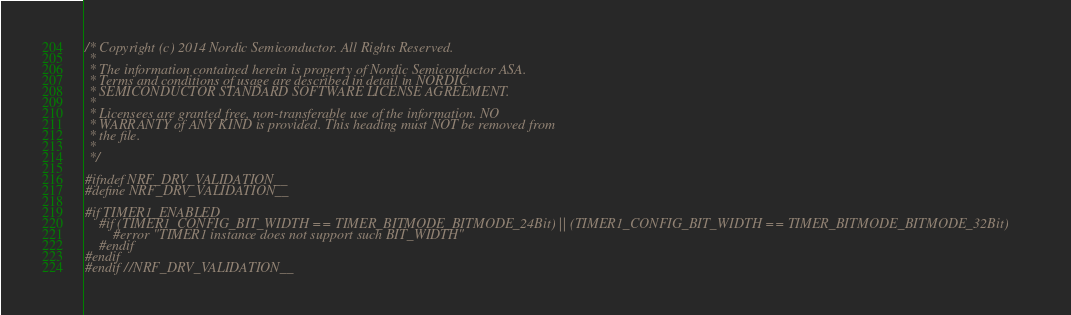<code> <loc_0><loc_0><loc_500><loc_500><_C_>/* Copyright (c) 2014 Nordic Semiconductor. All Rights Reserved.
 *
 * The information contained herein is property of Nordic Semiconductor ASA.
 * Terms and conditions of usage are described in detail in NORDIC
 * SEMICONDUCTOR STANDARD SOFTWARE LICENSE AGREEMENT.
 *
 * Licensees are granted free, non-transferable use of the information. NO
 * WARRANTY of ANY KIND is provided. This heading must NOT be removed from
 * the file.
 *
 */

#ifndef NRF_DRV_VALIDATION__
#define NRF_DRV_VALIDATION__

#if TIMER1_ENABLED
    #if (TIMER1_CONFIG_BIT_WIDTH == TIMER_BITMODE_BITMODE_24Bit) || (TIMER1_CONFIG_BIT_WIDTH == TIMER_BITMODE_BITMODE_32Bit)
        #error "TIMER1 instance does not support such BIT_WIDTH"
    #endif
#endif
#endif //NRF_DRV_VALIDATION__
</code> 